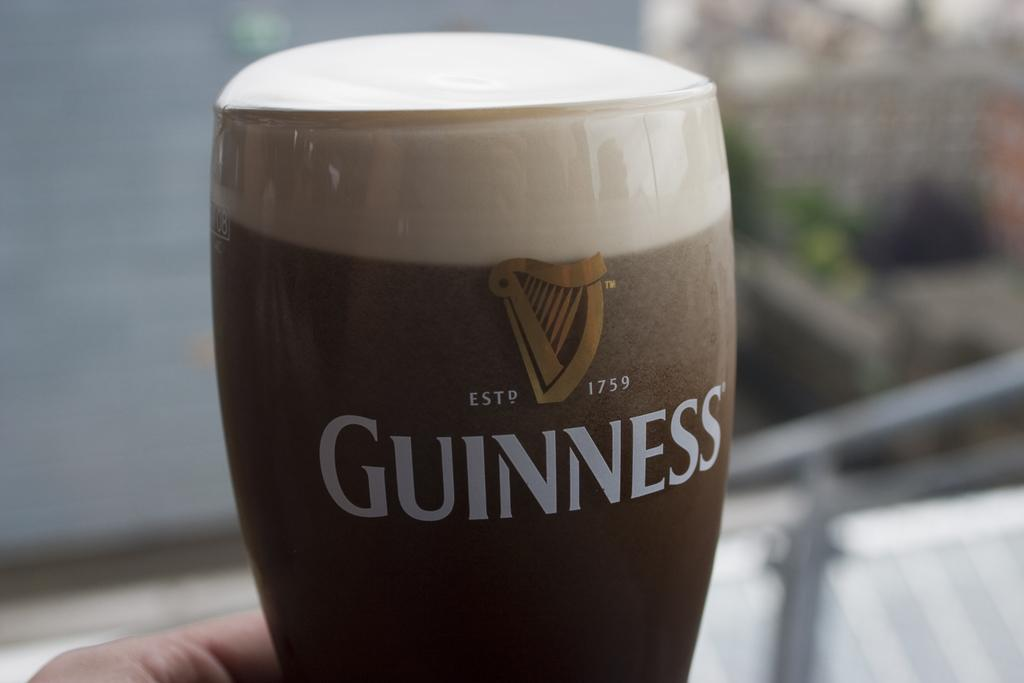<image>
Share a concise interpretation of the image provided. A person holds a glass of Guinness beer. 